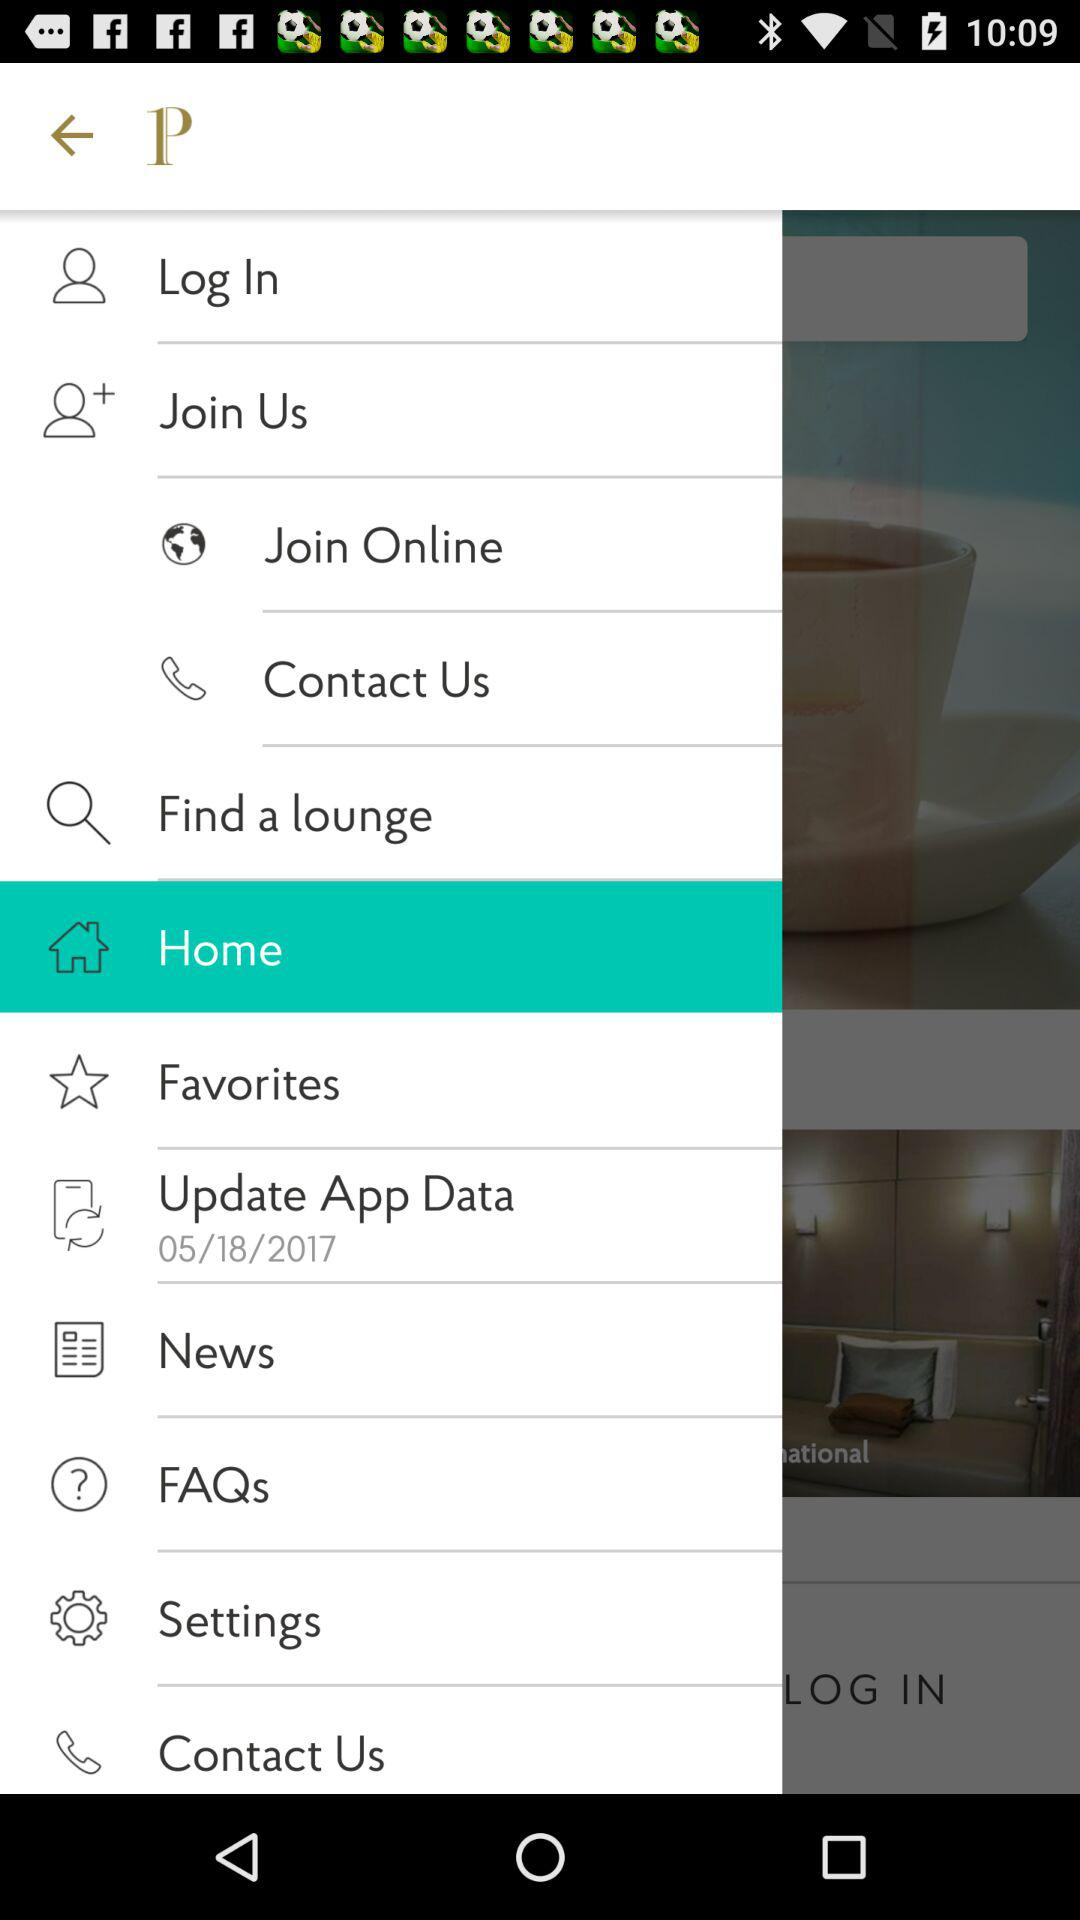When was the app data last updated? The app data was last updated on May 18, 2017. 